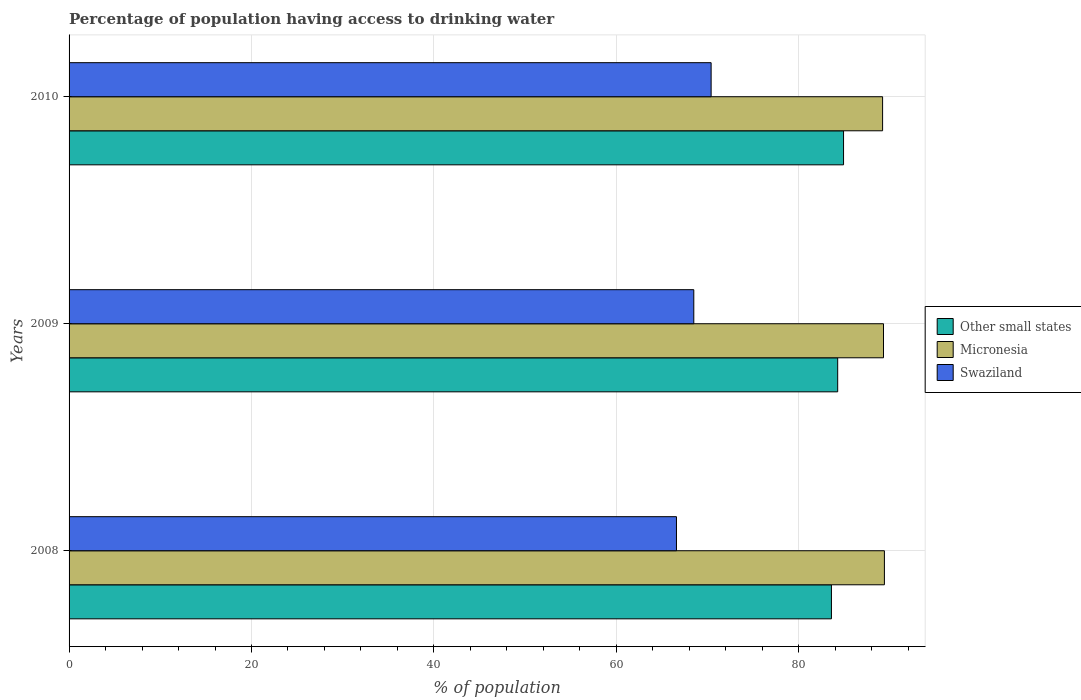How many different coloured bars are there?
Offer a terse response. 3. How many groups of bars are there?
Provide a succinct answer. 3. Are the number of bars per tick equal to the number of legend labels?
Ensure brevity in your answer.  Yes. Are the number of bars on each tick of the Y-axis equal?
Give a very brief answer. Yes. How many bars are there on the 2nd tick from the top?
Ensure brevity in your answer.  3. What is the label of the 2nd group of bars from the top?
Your answer should be very brief. 2009. In how many cases, is the number of bars for a given year not equal to the number of legend labels?
Give a very brief answer. 0. What is the percentage of population having access to drinking water in Micronesia in 2008?
Provide a succinct answer. 89.4. Across all years, what is the maximum percentage of population having access to drinking water in Micronesia?
Your response must be concise. 89.4. Across all years, what is the minimum percentage of population having access to drinking water in Micronesia?
Keep it short and to the point. 89.2. In which year was the percentage of population having access to drinking water in Other small states maximum?
Offer a terse response. 2010. What is the total percentage of population having access to drinking water in Micronesia in the graph?
Your answer should be compact. 267.9. What is the difference between the percentage of population having access to drinking water in Swaziland in 2009 and that in 2010?
Your answer should be compact. -1.9. What is the difference between the percentage of population having access to drinking water in Micronesia in 2009 and the percentage of population having access to drinking water in Swaziland in 2008?
Keep it short and to the point. 22.7. What is the average percentage of population having access to drinking water in Swaziland per year?
Offer a terse response. 68.5. In the year 2009, what is the difference between the percentage of population having access to drinking water in Swaziland and percentage of population having access to drinking water in Micronesia?
Make the answer very short. -20.8. What is the ratio of the percentage of population having access to drinking water in Swaziland in 2009 to that in 2010?
Make the answer very short. 0.97. Is the difference between the percentage of population having access to drinking water in Swaziland in 2008 and 2010 greater than the difference between the percentage of population having access to drinking water in Micronesia in 2008 and 2010?
Your response must be concise. No. What is the difference between the highest and the second highest percentage of population having access to drinking water in Micronesia?
Offer a very short reply. 0.1. What is the difference between the highest and the lowest percentage of population having access to drinking water in Micronesia?
Give a very brief answer. 0.2. What does the 3rd bar from the top in 2008 represents?
Offer a very short reply. Other small states. What does the 1st bar from the bottom in 2010 represents?
Keep it short and to the point. Other small states. Are all the bars in the graph horizontal?
Provide a succinct answer. Yes. What is the difference between two consecutive major ticks on the X-axis?
Make the answer very short. 20. Does the graph contain grids?
Offer a very short reply. Yes. How many legend labels are there?
Keep it short and to the point. 3. How are the legend labels stacked?
Keep it short and to the point. Vertical. What is the title of the graph?
Make the answer very short. Percentage of population having access to drinking water. What is the label or title of the X-axis?
Offer a terse response. % of population. What is the label or title of the Y-axis?
Give a very brief answer. Years. What is the % of population in Other small states in 2008?
Your answer should be compact. 83.59. What is the % of population of Micronesia in 2008?
Your response must be concise. 89.4. What is the % of population in Swaziland in 2008?
Provide a succinct answer. 66.6. What is the % of population of Other small states in 2009?
Make the answer very short. 84.28. What is the % of population of Micronesia in 2009?
Make the answer very short. 89.3. What is the % of population of Swaziland in 2009?
Offer a terse response. 68.5. What is the % of population of Other small states in 2010?
Offer a very short reply. 84.92. What is the % of population in Micronesia in 2010?
Give a very brief answer. 89.2. What is the % of population of Swaziland in 2010?
Give a very brief answer. 70.4. Across all years, what is the maximum % of population in Other small states?
Give a very brief answer. 84.92. Across all years, what is the maximum % of population in Micronesia?
Provide a succinct answer. 89.4. Across all years, what is the maximum % of population of Swaziland?
Offer a very short reply. 70.4. Across all years, what is the minimum % of population in Other small states?
Your response must be concise. 83.59. Across all years, what is the minimum % of population of Micronesia?
Provide a succinct answer. 89.2. Across all years, what is the minimum % of population of Swaziland?
Offer a terse response. 66.6. What is the total % of population of Other small states in the graph?
Make the answer very short. 252.79. What is the total % of population in Micronesia in the graph?
Give a very brief answer. 267.9. What is the total % of population in Swaziland in the graph?
Offer a very short reply. 205.5. What is the difference between the % of population in Other small states in 2008 and that in 2009?
Provide a succinct answer. -0.69. What is the difference between the % of population in Micronesia in 2008 and that in 2009?
Offer a terse response. 0.1. What is the difference between the % of population of Other small states in 2008 and that in 2010?
Your answer should be compact. -1.33. What is the difference between the % of population in Other small states in 2009 and that in 2010?
Your answer should be compact. -0.64. What is the difference between the % of population of Swaziland in 2009 and that in 2010?
Make the answer very short. -1.9. What is the difference between the % of population in Other small states in 2008 and the % of population in Micronesia in 2009?
Your response must be concise. -5.71. What is the difference between the % of population in Other small states in 2008 and the % of population in Swaziland in 2009?
Make the answer very short. 15.09. What is the difference between the % of population in Micronesia in 2008 and the % of population in Swaziland in 2009?
Your answer should be very brief. 20.9. What is the difference between the % of population of Other small states in 2008 and the % of population of Micronesia in 2010?
Keep it short and to the point. -5.61. What is the difference between the % of population of Other small states in 2008 and the % of population of Swaziland in 2010?
Your response must be concise. 13.19. What is the difference between the % of population of Other small states in 2009 and the % of population of Micronesia in 2010?
Keep it short and to the point. -4.92. What is the difference between the % of population in Other small states in 2009 and the % of population in Swaziland in 2010?
Provide a short and direct response. 13.88. What is the difference between the % of population of Micronesia in 2009 and the % of population of Swaziland in 2010?
Make the answer very short. 18.9. What is the average % of population in Other small states per year?
Your answer should be compact. 84.26. What is the average % of population in Micronesia per year?
Provide a short and direct response. 89.3. What is the average % of population of Swaziland per year?
Provide a short and direct response. 68.5. In the year 2008, what is the difference between the % of population in Other small states and % of population in Micronesia?
Ensure brevity in your answer.  -5.81. In the year 2008, what is the difference between the % of population of Other small states and % of population of Swaziland?
Keep it short and to the point. 16.99. In the year 2008, what is the difference between the % of population in Micronesia and % of population in Swaziland?
Offer a very short reply. 22.8. In the year 2009, what is the difference between the % of population in Other small states and % of population in Micronesia?
Your answer should be very brief. -5.02. In the year 2009, what is the difference between the % of population of Other small states and % of population of Swaziland?
Your answer should be compact. 15.78. In the year 2009, what is the difference between the % of population in Micronesia and % of population in Swaziland?
Give a very brief answer. 20.8. In the year 2010, what is the difference between the % of population of Other small states and % of population of Micronesia?
Your answer should be very brief. -4.28. In the year 2010, what is the difference between the % of population in Other small states and % of population in Swaziland?
Give a very brief answer. 14.52. In the year 2010, what is the difference between the % of population in Micronesia and % of population in Swaziland?
Your response must be concise. 18.8. What is the ratio of the % of population in Other small states in 2008 to that in 2009?
Make the answer very short. 0.99. What is the ratio of the % of population in Swaziland in 2008 to that in 2009?
Provide a short and direct response. 0.97. What is the ratio of the % of population in Other small states in 2008 to that in 2010?
Provide a short and direct response. 0.98. What is the ratio of the % of population in Micronesia in 2008 to that in 2010?
Offer a very short reply. 1. What is the ratio of the % of population in Swaziland in 2008 to that in 2010?
Ensure brevity in your answer.  0.95. What is the ratio of the % of population in Other small states in 2009 to that in 2010?
Make the answer very short. 0.99. What is the ratio of the % of population of Micronesia in 2009 to that in 2010?
Your answer should be compact. 1. What is the ratio of the % of population in Swaziland in 2009 to that in 2010?
Your answer should be very brief. 0.97. What is the difference between the highest and the second highest % of population of Other small states?
Your response must be concise. 0.64. What is the difference between the highest and the second highest % of population in Swaziland?
Provide a succinct answer. 1.9. What is the difference between the highest and the lowest % of population in Other small states?
Provide a short and direct response. 1.33. 